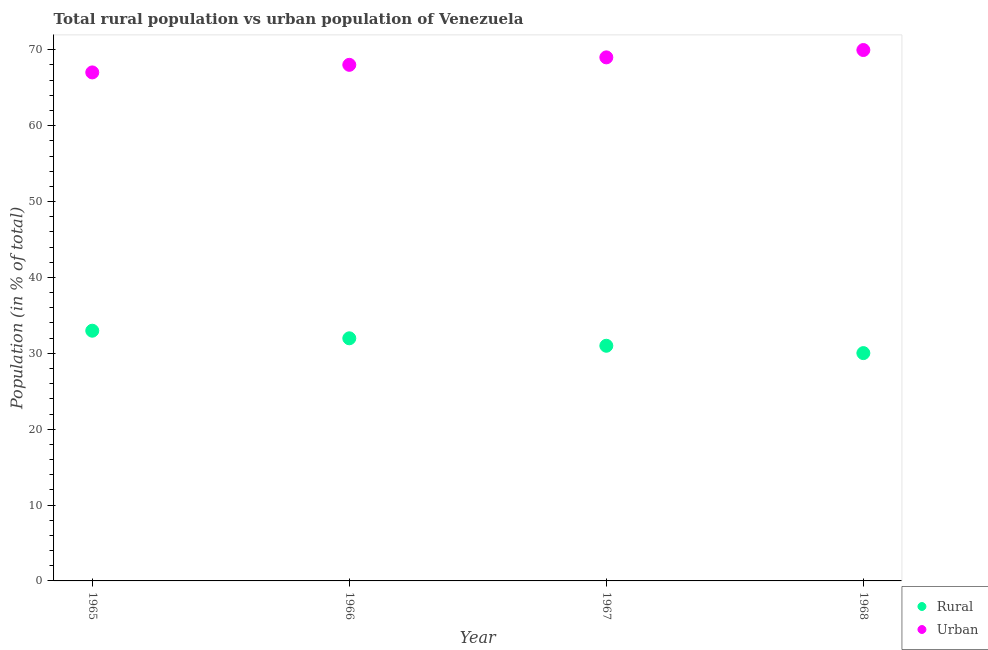How many different coloured dotlines are there?
Make the answer very short. 2. Is the number of dotlines equal to the number of legend labels?
Give a very brief answer. Yes. What is the urban population in 1968?
Your answer should be very brief. 69.97. Across all years, what is the maximum urban population?
Ensure brevity in your answer.  69.97. Across all years, what is the minimum rural population?
Offer a terse response. 30.03. In which year was the urban population maximum?
Provide a succinct answer. 1968. In which year was the urban population minimum?
Your response must be concise. 1965. What is the total urban population in the graph?
Your answer should be compact. 274.02. What is the difference between the rural population in 1965 and that in 1967?
Give a very brief answer. 1.98. What is the difference between the rural population in 1966 and the urban population in 1968?
Give a very brief answer. -37.99. What is the average rural population per year?
Make the answer very short. 31.49. In the year 1968, what is the difference between the rural population and urban population?
Provide a succinct answer. -39.95. In how many years, is the urban population greater than 54 %?
Make the answer very short. 4. What is the ratio of the rural population in 1965 to that in 1967?
Make the answer very short. 1.06. Is the rural population in 1966 less than that in 1968?
Make the answer very short. No. Is the difference between the urban population in 1966 and 1968 greater than the difference between the rural population in 1966 and 1968?
Your answer should be compact. No. What is the difference between the highest and the second highest urban population?
Give a very brief answer. 0.97. What is the difference between the highest and the lowest urban population?
Provide a short and direct response. 2.95. Is the urban population strictly less than the rural population over the years?
Your answer should be compact. No. How many years are there in the graph?
Offer a terse response. 4. What is the difference between two consecutive major ticks on the Y-axis?
Provide a short and direct response. 10. Are the values on the major ticks of Y-axis written in scientific E-notation?
Offer a terse response. No. Does the graph contain grids?
Provide a short and direct response. No. Where does the legend appear in the graph?
Your answer should be compact. Bottom right. How many legend labels are there?
Offer a terse response. 2. What is the title of the graph?
Make the answer very short. Total rural population vs urban population of Venezuela. What is the label or title of the X-axis?
Your answer should be very brief. Year. What is the label or title of the Y-axis?
Keep it short and to the point. Population (in % of total). What is the Population (in % of total) in Rural in 1965?
Make the answer very short. 32.98. What is the Population (in % of total) in Urban in 1965?
Your answer should be compact. 67.02. What is the Population (in % of total) in Rural in 1966?
Offer a terse response. 31.98. What is the Population (in % of total) in Urban in 1966?
Your response must be concise. 68.02. What is the Population (in % of total) in Rural in 1967?
Provide a succinct answer. 31. What is the Population (in % of total) in Urban in 1967?
Give a very brief answer. 69. What is the Population (in % of total) in Rural in 1968?
Your answer should be very brief. 30.03. What is the Population (in % of total) of Urban in 1968?
Keep it short and to the point. 69.97. Across all years, what is the maximum Population (in % of total) of Rural?
Your answer should be compact. 32.98. Across all years, what is the maximum Population (in % of total) in Urban?
Keep it short and to the point. 69.97. Across all years, what is the minimum Population (in % of total) of Rural?
Make the answer very short. 30.03. Across all years, what is the minimum Population (in % of total) of Urban?
Offer a very short reply. 67.02. What is the total Population (in % of total) in Rural in the graph?
Ensure brevity in your answer.  125.98. What is the total Population (in % of total) of Urban in the graph?
Your answer should be very brief. 274.02. What is the difference between the Population (in % of total) of Rural in 1965 and that in 1967?
Make the answer very short. 1.98. What is the difference between the Population (in % of total) in Urban in 1965 and that in 1967?
Offer a terse response. -1.98. What is the difference between the Population (in % of total) in Rural in 1965 and that in 1968?
Offer a very short reply. 2.95. What is the difference between the Population (in % of total) in Urban in 1965 and that in 1968?
Your answer should be compact. -2.95. What is the difference between the Population (in % of total) in Rural in 1966 and that in 1967?
Provide a succinct answer. 0.98. What is the difference between the Population (in % of total) of Urban in 1966 and that in 1967?
Your answer should be very brief. -0.98. What is the difference between the Population (in % of total) in Rural in 1966 and that in 1968?
Offer a terse response. 1.95. What is the difference between the Population (in % of total) in Urban in 1966 and that in 1968?
Offer a terse response. -1.95. What is the difference between the Population (in % of total) in Urban in 1967 and that in 1968?
Ensure brevity in your answer.  -0.97. What is the difference between the Population (in % of total) in Rural in 1965 and the Population (in % of total) in Urban in 1966?
Provide a short and direct response. -35.04. What is the difference between the Population (in % of total) in Rural in 1965 and the Population (in % of total) in Urban in 1967?
Your answer should be very brief. -36.03. What is the difference between the Population (in % of total) of Rural in 1965 and the Population (in % of total) of Urban in 1968?
Make the answer very short. -36.99. What is the difference between the Population (in % of total) of Rural in 1966 and the Population (in % of total) of Urban in 1967?
Keep it short and to the point. -37.03. What is the difference between the Population (in % of total) of Rural in 1966 and the Population (in % of total) of Urban in 1968?
Ensure brevity in your answer.  -37.99. What is the difference between the Population (in % of total) in Rural in 1967 and the Population (in % of total) in Urban in 1968?
Give a very brief answer. -38.98. What is the average Population (in % of total) of Rural per year?
Your answer should be very brief. 31.49. What is the average Population (in % of total) in Urban per year?
Your response must be concise. 68.51. In the year 1965, what is the difference between the Population (in % of total) in Rural and Population (in % of total) in Urban?
Offer a terse response. -34.04. In the year 1966, what is the difference between the Population (in % of total) in Rural and Population (in % of total) in Urban?
Provide a succinct answer. -36.04. In the year 1967, what is the difference between the Population (in % of total) of Rural and Population (in % of total) of Urban?
Keep it short and to the point. -38.01. In the year 1968, what is the difference between the Population (in % of total) in Rural and Population (in % of total) in Urban?
Provide a short and direct response. -39.95. What is the ratio of the Population (in % of total) in Rural in 1965 to that in 1966?
Give a very brief answer. 1.03. What is the ratio of the Population (in % of total) of Urban in 1965 to that in 1966?
Keep it short and to the point. 0.99. What is the ratio of the Population (in % of total) in Rural in 1965 to that in 1967?
Your answer should be very brief. 1.06. What is the ratio of the Population (in % of total) in Urban in 1965 to that in 1967?
Your response must be concise. 0.97. What is the ratio of the Population (in % of total) in Rural in 1965 to that in 1968?
Provide a short and direct response. 1.1. What is the ratio of the Population (in % of total) in Urban in 1965 to that in 1968?
Your answer should be very brief. 0.96. What is the ratio of the Population (in % of total) in Rural in 1966 to that in 1967?
Keep it short and to the point. 1.03. What is the ratio of the Population (in % of total) of Urban in 1966 to that in 1967?
Give a very brief answer. 0.99. What is the ratio of the Population (in % of total) of Rural in 1966 to that in 1968?
Offer a very short reply. 1.06. What is the ratio of the Population (in % of total) in Urban in 1966 to that in 1968?
Your answer should be very brief. 0.97. What is the ratio of the Population (in % of total) in Rural in 1967 to that in 1968?
Provide a succinct answer. 1.03. What is the ratio of the Population (in % of total) of Urban in 1967 to that in 1968?
Offer a terse response. 0.99. What is the difference between the highest and the second highest Population (in % of total) in Rural?
Give a very brief answer. 1. What is the difference between the highest and the lowest Population (in % of total) in Rural?
Provide a short and direct response. 2.95. What is the difference between the highest and the lowest Population (in % of total) in Urban?
Give a very brief answer. 2.95. 